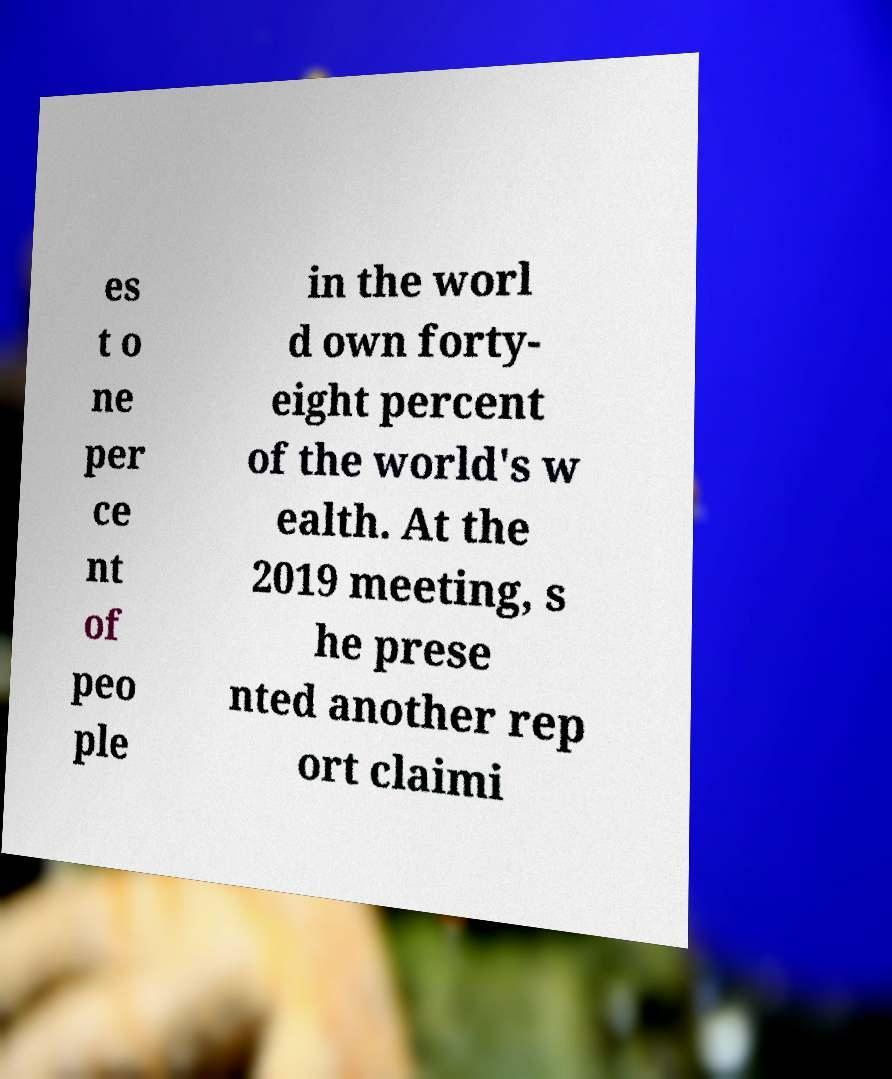Can you accurately transcribe the text from the provided image for me? es t o ne per ce nt of peo ple in the worl d own forty- eight percent of the world's w ealth. At the 2019 meeting, s he prese nted another rep ort claimi 